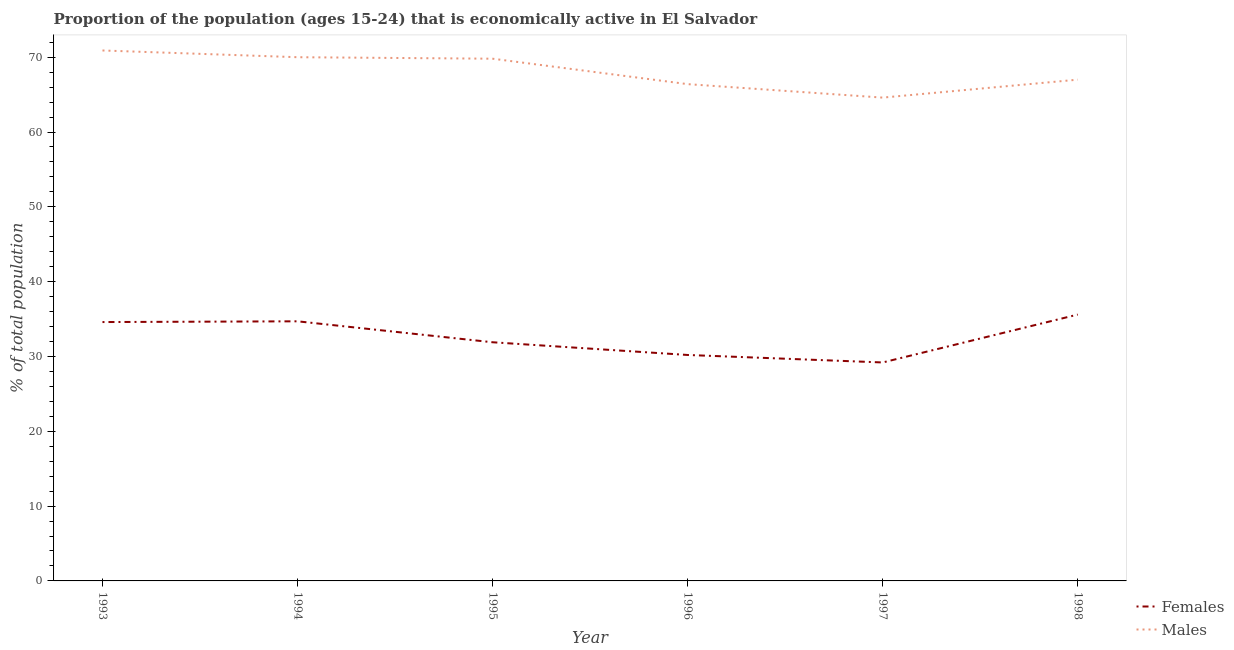How many different coloured lines are there?
Your answer should be compact. 2. Is the number of lines equal to the number of legend labels?
Your answer should be very brief. Yes. What is the percentage of economically active female population in 1998?
Give a very brief answer. 35.6. Across all years, what is the maximum percentage of economically active male population?
Your answer should be compact. 70.9. Across all years, what is the minimum percentage of economically active male population?
Give a very brief answer. 64.6. What is the total percentage of economically active male population in the graph?
Ensure brevity in your answer.  408.7. What is the difference between the percentage of economically active male population in 1993 and that in 1997?
Make the answer very short. 6.3. What is the difference between the percentage of economically active female population in 1994 and the percentage of economically active male population in 1993?
Your response must be concise. -36.2. What is the average percentage of economically active male population per year?
Your response must be concise. 68.12. In the year 1997, what is the difference between the percentage of economically active male population and percentage of economically active female population?
Offer a very short reply. 35.4. In how many years, is the percentage of economically active female population greater than 14 %?
Provide a succinct answer. 6. What is the ratio of the percentage of economically active female population in 1997 to that in 1998?
Keep it short and to the point. 0.82. Is the percentage of economically active female population in 1995 less than that in 1998?
Offer a terse response. Yes. What is the difference between the highest and the second highest percentage of economically active male population?
Make the answer very short. 0.9. What is the difference between the highest and the lowest percentage of economically active female population?
Your answer should be compact. 6.4. Is the percentage of economically active female population strictly greater than the percentage of economically active male population over the years?
Give a very brief answer. No. What is the difference between two consecutive major ticks on the Y-axis?
Offer a very short reply. 10. Are the values on the major ticks of Y-axis written in scientific E-notation?
Make the answer very short. No. Does the graph contain any zero values?
Offer a very short reply. No. How many legend labels are there?
Provide a short and direct response. 2. What is the title of the graph?
Give a very brief answer. Proportion of the population (ages 15-24) that is economically active in El Salvador. Does "Grants" appear as one of the legend labels in the graph?
Ensure brevity in your answer.  No. What is the label or title of the X-axis?
Provide a short and direct response. Year. What is the label or title of the Y-axis?
Provide a short and direct response. % of total population. What is the % of total population in Females in 1993?
Your response must be concise. 34.6. What is the % of total population in Males in 1993?
Provide a short and direct response. 70.9. What is the % of total population of Females in 1994?
Your answer should be compact. 34.7. What is the % of total population of Males in 1994?
Make the answer very short. 70. What is the % of total population of Females in 1995?
Your answer should be compact. 31.9. What is the % of total population in Males in 1995?
Offer a very short reply. 69.8. What is the % of total population of Females in 1996?
Give a very brief answer. 30.2. What is the % of total population in Males in 1996?
Your answer should be compact. 66.4. What is the % of total population in Females in 1997?
Offer a terse response. 29.2. What is the % of total population in Males in 1997?
Offer a very short reply. 64.6. What is the % of total population of Females in 1998?
Offer a very short reply. 35.6. Across all years, what is the maximum % of total population of Females?
Offer a very short reply. 35.6. Across all years, what is the maximum % of total population of Males?
Offer a very short reply. 70.9. Across all years, what is the minimum % of total population of Females?
Your answer should be compact. 29.2. Across all years, what is the minimum % of total population in Males?
Provide a short and direct response. 64.6. What is the total % of total population in Females in the graph?
Offer a very short reply. 196.2. What is the total % of total population in Males in the graph?
Your answer should be compact. 408.7. What is the difference between the % of total population of Females in 1993 and that in 1994?
Ensure brevity in your answer.  -0.1. What is the difference between the % of total population of Males in 1993 and that in 1994?
Offer a terse response. 0.9. What is the difference between the % of total population of Females in 1993 and that in 1995?
Your response must be concise. 2.7. What is the difference between the % of total population in Females in 1993 and that in 1996?
Your answer should be very brief. 4.4. What is the difference between the % of total population in Females in 1993 and that in 1997?
Provide a succinct answer. 5.4. What is the difference between the % of total population in Males in 1993 and that in 1997?
Your answer should be very brief. 6.3. What is the difference between the % of total population of Females in 1994 and that in 1995?
Provide a succinct answer. 2.8. What is the difference between the % of total population in Males in 1994 and that in 1995?
Offer a very short reply. 0.2. What is the difference between the % of total population in Females in 1994 and that in 1996?
Your response must be concise. 4.5. What is the difference between the % of total population of Males in 1994 and that in 1996?
Offer a terse response. 3.6. What is the difference between the % of total population in Females in 1994 and that in 1997?
Make the answer very short. 5.5. What is the difference between the % of total population of Males in 1994 and that in 1998?
Offer a very short reply. 3. What is the difference between the % of total population of Males in 1995 and that in 1997?
Your answer should be compact. 5.2. What is the difference between the % of total population in Males in 1996 and that in 1998?
Keep it short and to the point. -0.6. What is the difference between the % of total population in Females in 1997 and that in 1998?
Offer a terse response. -6.4. What is the difference between the % of total population of Females in 1993 and the % of total population of Males in 1994?
Provide a succinct answer. -35.4. What is the difference between the % of total population of Females in 1993 and the % of total population of Males in 1995?
Offer a terse response. -35.2. What is the difference between the % of total population of Females in 1993 and the % of total population of Males in 1996?
Ensure brevity in your answer.  -31.8. What is the difference between the % of total population of Females in 1993 and the % of total population of Males in 1998?
Make the answer very short. -32.4. What is the difference between the % of total population of Females in 1994 and the % of total population of Males in 1995?
Give a very brief answer. -35.1. What is the difference between the % of total population of Females in 1994 and the % of total population of Males in 1996?
Ensure brevity in your answer.  -31.7. What is the difference between the % of total population of Females in 1994 and the % of total population of Males in 1997?
Give a very brief answer. -29.9. What is the difference between the % of total population in Females in 1994 and the % of total population in Males in 1998?
Offer a very short reply. -32.3. What is the difference between the % of total population of Females in 1995 and the % of total population of Males in 1996?
Provide a succinct answer. -34.5. What is the difference between the % of total population of Females in 1995 and the % of total population of Males in 1997?
Your answer should be very brief. -32.7. What is the difference between the % of total population of Females in 1995 and the % of total population of Males in 1998?
Your response must be concise. -35.1. What is the difference between the % of total population of Females in 1996 and the % of total population of Males in 1997?
Give a very brief answer. -34.4. What is the difference between the % of total population of Females in 1996 and the % of total population of Males in 1998?
Offer a very short reply. -36.8. What is the difference between the % of total population in Females in 1997 and the % of total population in Males in 1998?
Keep it short and to the point. -37.8. What is the average % of total population in Females per year?
Offer a very short reply. 32.7. What is the average % of total population in Males per year?
Provide a short and direct response. 68.12. In the year 1993, what is the difference between the % of total population in Females and % of total population in Males?
Your answer should be very brief. -36.3. In the year 1994, what is the difference between the % of total population of Females and % of total population of Males?
Offer a very short reply. -35.3. In the year 1995, what is the difference between the % of total population in Females and % of total population in Males?
Your answer should be very brief. -37.9. In the year 1996, what is the difference between the % of total population in Females and % of total population in Males?
Your answer should be compact. -36.2. In the year 1997, what is the difference between the % of total population of Females and % of total population of Males?
Offer a very short reply. -35.4. In the year 1998, what is the difference between the % of total population in Females and % of total population in Males?
Your answer should be very brief. -31.4. What is the ratio of the % of total population in Males in 1993 to that in 1994?
Keep it short and to the point. 1.01. What is the ratio of the % of total population in Females in 1993 to that in 1995?
Give a very brief answer. 1.08. What is the ratio of the % of total population in Males in 1993 to that in 1995?
Offer a terse response. 1.02. What is the ratio of the % of total population of Females in 1993 to that in 1996?
Provide a succinct answer. 1.15. What is the ratio of the % of total population of Males in 1993 to that in 1996?
Offer a very short reply. 1.07. What is the ratio of the % of total population of Females in 1993 to that in 1997?
Offer a terse response. 1.18. What is the ratio of the % of total population of Males in 1993 to that in 1997?
Your response must be concise. 1.1. What is the ratio of the % of total population of Females in 1993 to that in 1998?
Keep it short and to the point. 0.97. What is the ratio of the % of total population in Males in 1993 to that in 1998?
Ensure brevity in your answer.  1.06. What is the ratio of the % of total population in Females in 1994 to that in 1995?
Offer a terse response. 1.09. What is the ratio of the % of total population of Males in 1994 to that in 1995?
Offer a terse response. 1. What is the ratio of the % of total population in Females in 1994 to that in 1996?
Ensure brevity in your answer.  1.15. What is the ratio of the % of total population in Males in 1994 to that in 1996?
Your answer should be compact. 1.05. What is the ratio of the % of total population of Females in 1994 to that in 1997?
Offer a terse response. 1.19. What is the ratio of the % of total population in Males in 1994 to that in 1997?
Give a very brief answer. 1.08. What is the ratio of the % of total population in Females in 1994 to that in 1998?
Give a very brief answer. 0.97. What is the ratio of the % of total population of Males in 1994 to that in 1998?
Your response must be concise. 1.04. What is the ratio of the % of total population of Females in 1995 to that in 1996?
Your answer should be very brief. 1.06. What is the ratio of the % of total population in Males in 1995 to that in 1996?
Keep it short and to the point. 1.05. What is the ratio of the % of total population in Females in 1995 to that in 1997?
Your response must be concise. 1.09. What is the ratio of the % of total population in Males in 1995 to that in 1997?
Keep it short and to the point. 1.08. What is the ratio of the % of total population in Females in 1995 to that in 1998?
Your answer should be very brief. 0.9. What is the ratio of the % of total population in Males in 1995 to that in 1998?
Keep it short and to the point. 1.04. What is the ratio of the % of total population in Females in 1996 to that in 1997?
Offer a terse response. 1.03. What is the ratio of the % of total population of Males in 1996 to that in 1997?
Provide a short and direct response. 1.03. What is the ratio of the % of total population of Females in 1996 to that in 1998?
Make the answer very short. 0.85. What is the ratio of the % of total population in Males in 1996 to that in 1998?
Offer a terse response. 0.99. What is the ratio of the % of total population in Females in 1997 to that in 1998?
Ensure brevity in your answer.  0.82. What is the ratio of the % of total population in Males in 1997 to that in 1998?
Offer a terse response. 0.96. What is the difference between the highest and the second highest % of total population of Males?
Your response must be concise. 0.9. What is the difference between the highest and the lowest % of total population in Females?
Offer a terse response. 6.4. 